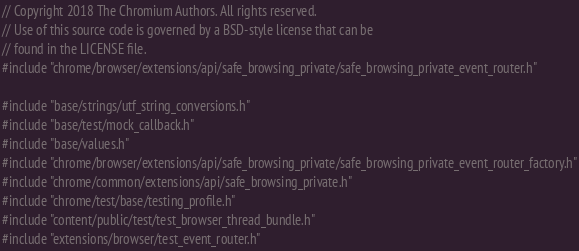Convert code to text. <code><loc_0><loc_0><loc_500><loc_500><_C++_>// Copyright 2018 The Chromium Authors. All rights reserved.
// Use of this source code is governed by a BSD-style license that can be
// found in the LICENSE file.
#include "chrome/browser/extensions/api/safe_browsing_private/safe_browsing_private_event_router.h"

#include "base/strings/utf_string_conversions.h"
#include "base/test/mock_callback.h"
#include "base/values.h"
#include "chrome/browser/extensions/api/safe_browsing_private/safe_browsing_private_event_router_factory.h"
#include "chrome/common/extensions/api/safe_browsing_private.h"
#include "chrome/test/base/testing_profile.h"
#include "content/public/test/test_browser_thread_bundle.h"
#include "extensions/browser/test_event_router.h"</code> 